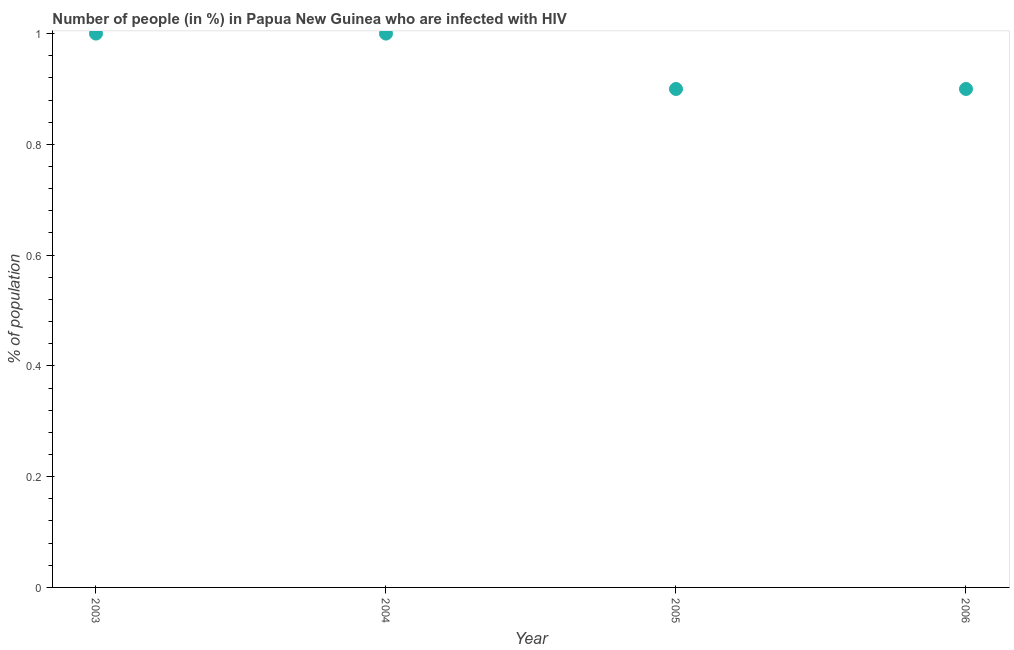In which year was the number of people infected with hiv maximum?
Your response must be concise. 2003. What is the difference between the number of people infected with hiv in 2004 and 2005?
Offer a terse response. 0.1. What is the average number of people infected with hiv per year?
Offer a terse response. 0.95. What is the median number of people infected with hiv?
Ensure brevity in your answer.  0.95. What is the ratio of the number of people infected with hiv in 2003 to that in 2005?
Give a very brief answer. 1.11. Is the sum of the number of people infected with hiv in 2003 and 2005 greater than the maximum number of people infected with hiv across all years?
Offer a terse response. Yes. What is the difference between the highest and the lowest number of people infected with hiv?
Give a very brief answer. 0.1. Does the number of people infected with hiv monotonically increase over the years?
Offer a very short reply. No. How many dotlines are there?
Keep it short and to the point. 1. How many years are there in the graph?
Your answer should be very brief. 4. What is the difference between two consecutive major ticks on the Y-axis?
Give a very brief answer. 0.2. Are the values on the major ticks of Y-axis written in scientific E-notation?
Give a very brief answer. No. Does the graph contain any zero values?
Offer a terse response. No. What is the title of the graph?
Provide a short and direct response. Number of people (in %) in Papua New Guinea who are infected with HIV. What is the label or title of the Y-axis?
Ensure brevity in your answer.  % of population. What is the % of population in 2006?
Make the answer very short. 0.9. What is the difference between the % of population in 2003 and 2004?
Offer a very short reply. 0. What is the difference between the % of population in 2004 and 2006?
Provide a succinct answer. 0.1. What is the ratio of the % of population in 2003 to that in 2004?
Provide a succinct answer. 1. What is the ratio of the % of population in 2003 to that in 2005?
Provide a succinct answer. 1.11. What is the ratio of the % of population in 2003 to that in 2006?
Offer a very short reply. 1.11. What is the ratio of the % of population in 2004 to that in 2005?
Offer a very short reply. 1.11. What is the ratio of the % of population in 2004 to that in 2006?
Provide a succinct answer. 1.11. 